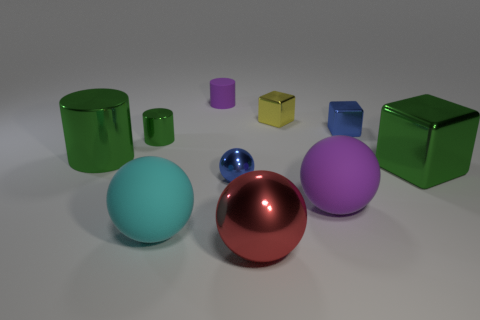Subtract all cubes. How many objects are left? 7 Add 6 cubes. How many cubes exist? 9 Subtract 1 red balls. How many objects are left? 9 Subtract all small gray cylinders. Subtract all red spheres. How many objects are left? 9 Add 9 tiny rubber cylinders. How many tiny rubber cylinders are left? 10 